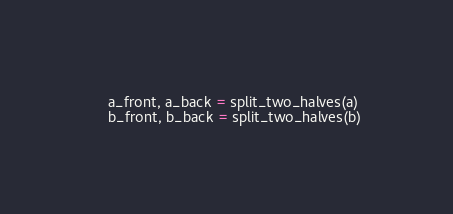<code> <loc_0><loc_0><loc_500><loc_500><_Python_>
    a_front, a_back = split_two_halves(a)
    b_front, b_back = split_two_halves(b)
</code> 